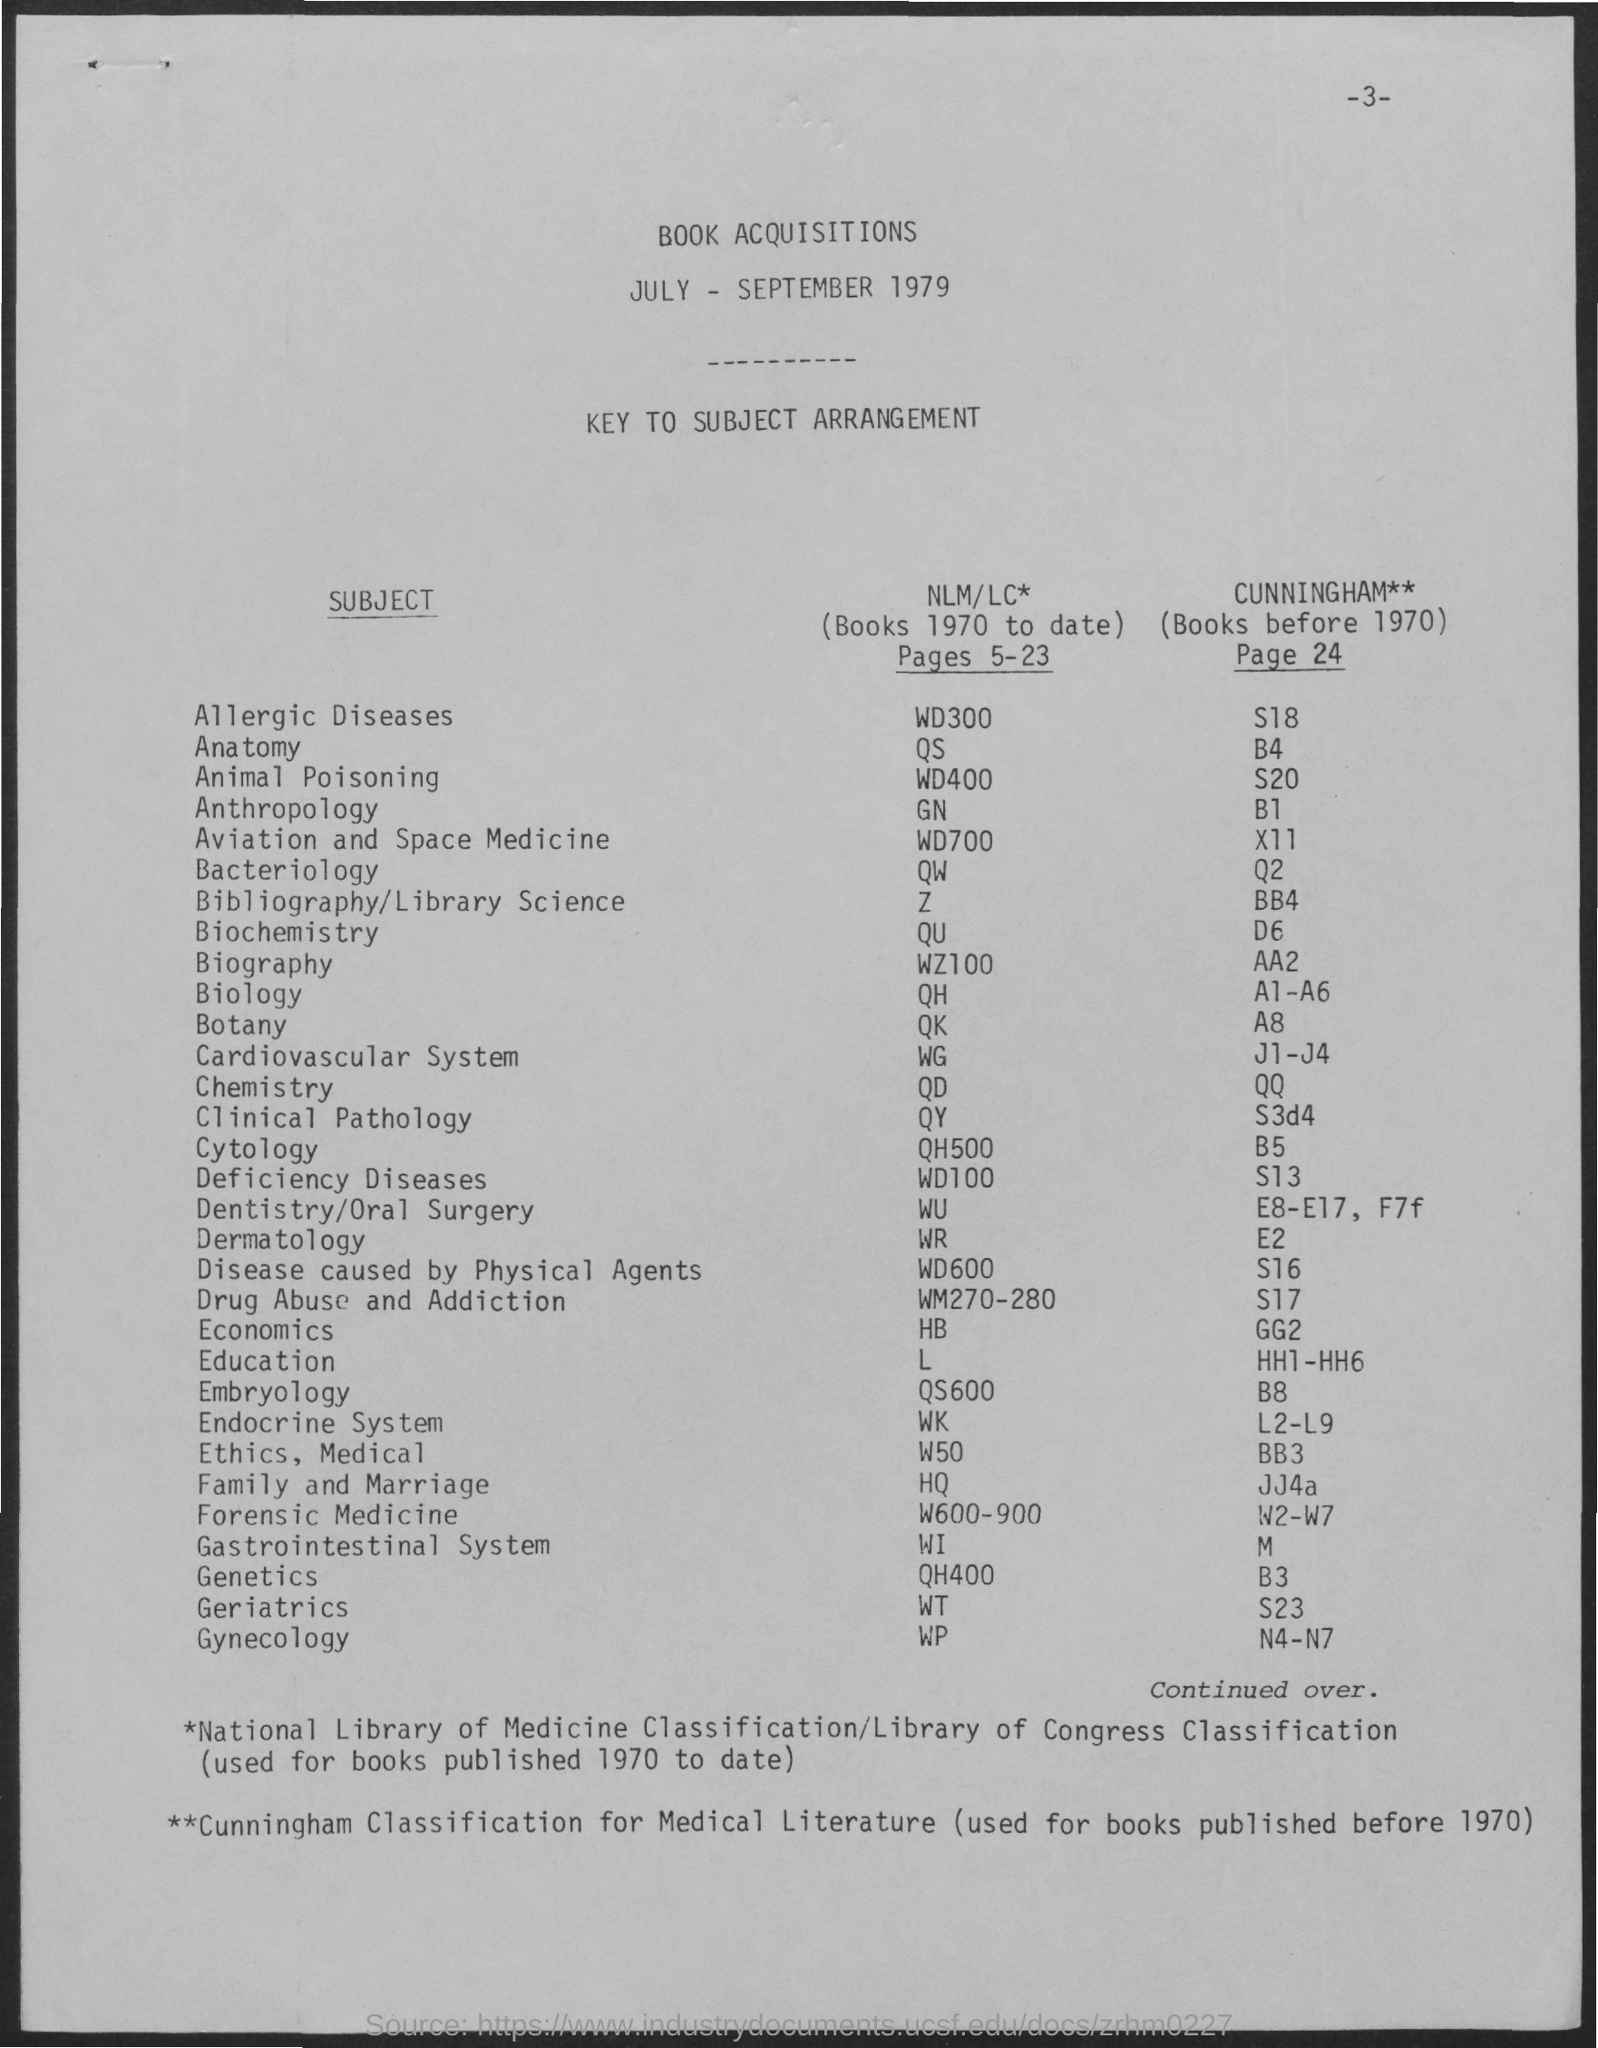What is the title of the document?
Your answer should be very brief. Book Acquisitions. What is the Page Number?
Make the answer very short. 3. Which classification is used for books published before 1970?
Provide a short and direct response. Cunningham Classification for Medical Literature. Which classification is used for books published 1970 to date?
Provide a short and direct response. Nlm/lc*. 